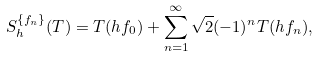<formula> <loc_0><loc_0><loc_500><loc_500>S _ { h } ^ { \{ f _ { n } \} } ( T ) = T ( h f _ { 0 } ) + \sum _ { n = 1 } ^ { \infty } \sqrt { 2 } ( - 1 ) ^ { n } T ( h f _ { n } ) ,</formula> 